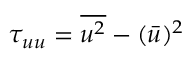<formula> <loc_0><loc_0><loc_500><loc_500>\tau _ { u u } = \overline { { u ^ { 2 } } } - ( \bar { u } ) ^ { 2 }</formula> 